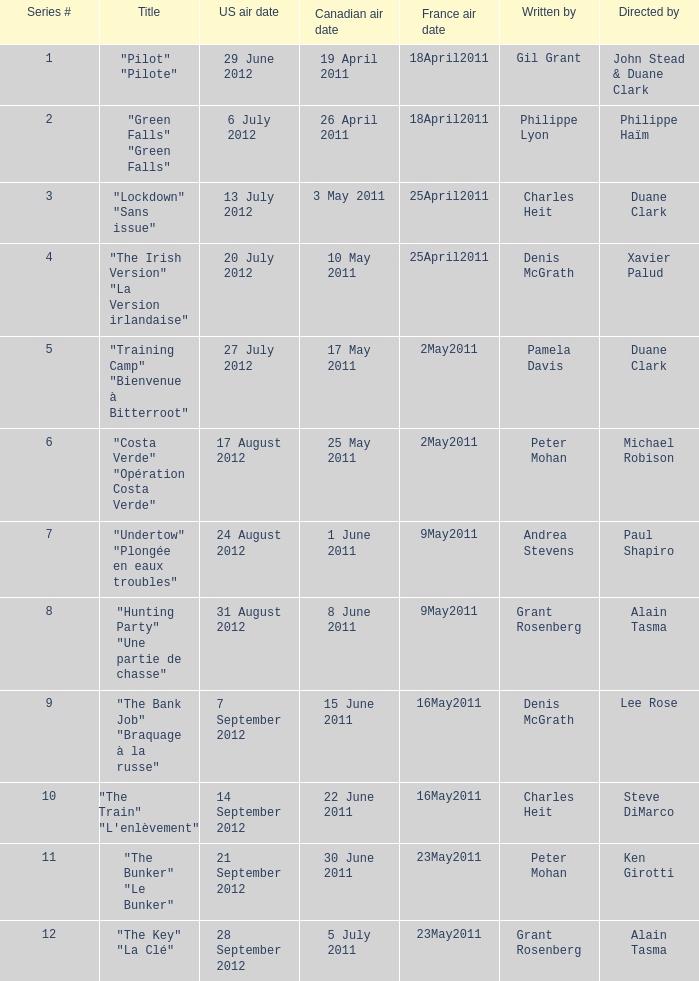What is the canadian air date when the US air date is 24 august 2012? 1 June 2011. I'm looking to parse the entire table for insights. Could you assist me with that? {'header': ['Series #', 'Title', 'US air date', 'Canadian air date', 'France air date', 'Written by', 'Directed by'], 'rows': [['1', '"Pilot" "Pilote"', '29 June 2012', '19 April 2011', '18April2011', 'Gil Grant', 'John Stead & Duane Clark'], ['2', '"Green Falls" "Green Falls"', '6 July 2012', '26 April 2011', '18April2011', 'Philippe Lyon', 'Philippe Haïm'], ['3', '"Lockdown" "Sans issue"', '13 July 2012', '3 May 2011', '25April2011', 'Charles Heit', 'Duane Clark'], ['4', '"The Irish Version" "La Version irlandaise"', '20 July 2012', '10 May 2011', '25April2011', 'Denis McGrath', 'Xavier Palud'], ['5', '"Training Camp" "Bienvenue à Bitterroot"', '27 July 2012', '17 May 2011', '2May2011', 'Pamela Davis', 'Duane Clark'], ['6', '"Costa Verde" "Opération Costa Verde"', '17 August 2012', '25 May 2011', '2May2011', 'Peter Mohan', 'Michael Robison'], ['7', '"Undertow" "Plongée en eaux troubles"', '24 August 2012', '1 June 2011', '9May2011', 'Andrea Stevens', 'Paul Shapiro'], ['8', '"Hunting Party" "Une partie de chasse"', '31 August 2012', '8 June 2011', '9May2011', 'Grant Rosenberg', 'Alain Tasma'], ['9', '"The Bank Job" "Braquage à la russe"', '7 September 2012', '15 June 2011', '16May2011', 'Denis McGrath', 'Lee Rose'], ['10', '"The Train" "L\'enlèvement"', '14 September 2012', '22 June 2011', '16May2011', 'Charles Heit', 'Steve DiMarco'], ['11', '"The Bunker" "Le Bunker"', '21 September 2012', '30 June 2011', '23May2011', 'Peter Mohan', 'Ken Girotti'], ['12', '"The Key" "La Clé"', '28 September 2012', '5 July 2011', '23May2011', 'Grant Rosenberg', 'Alain Tasma']]} 